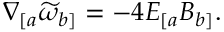Convert formula to latex. <formula><loc_0><loc_0><loc_500><loc_500>\nabla _ { [ a } \widetilde { \omega } _ { b ] } = - 4 E _ { [ a } B _ { b ] } .</formula> 